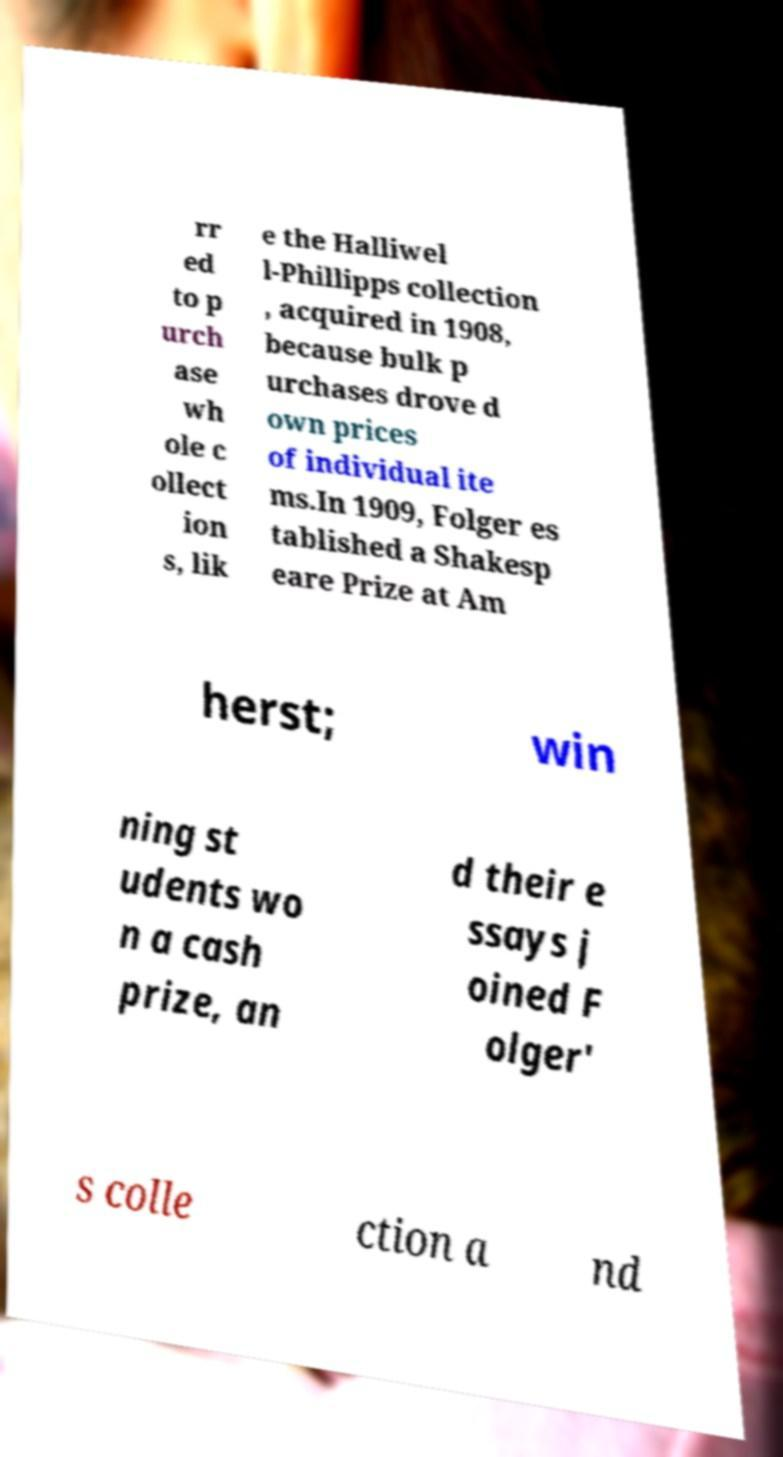For documentation purposes, I need the text within this image transcribed. Could you provide that? rr ed to p urch ase wh ole c ollect ion s, lik e the Halliwel l-Phillipps collection , acquired in 1908, because bulk p urchases drove d own prices of individual ite ms.In 1909, Folger es tablished a Shakesp eare Prize at Am herst; win ning st udents wo n a cash prize, an d their e ssays j oined F olger' s colle ction a nd 